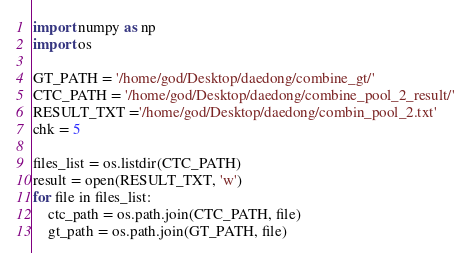<code> <loc_0><loc_0><loc_500><loc_500><_Python_>import numpy as np
import os

GT_PATH = '/home/god/Desktop/daedong/combine_gt/'
CTC_PATH = '/home/god/Desktop/daedong/combine_pool_2_result/'
RESULT_TXT ='/home/god/Desktop/daedong/combin_pool_2.txt'
chk = 5

files_list = os.listdir(CTC_PATH)
result = open(RESULT_TXT, 'w')
for file in files_list:
    ctc_path = os.path.join(CTC_PATH, file)
    gt_path = os.path.join(GT_PATH, file)</code> 